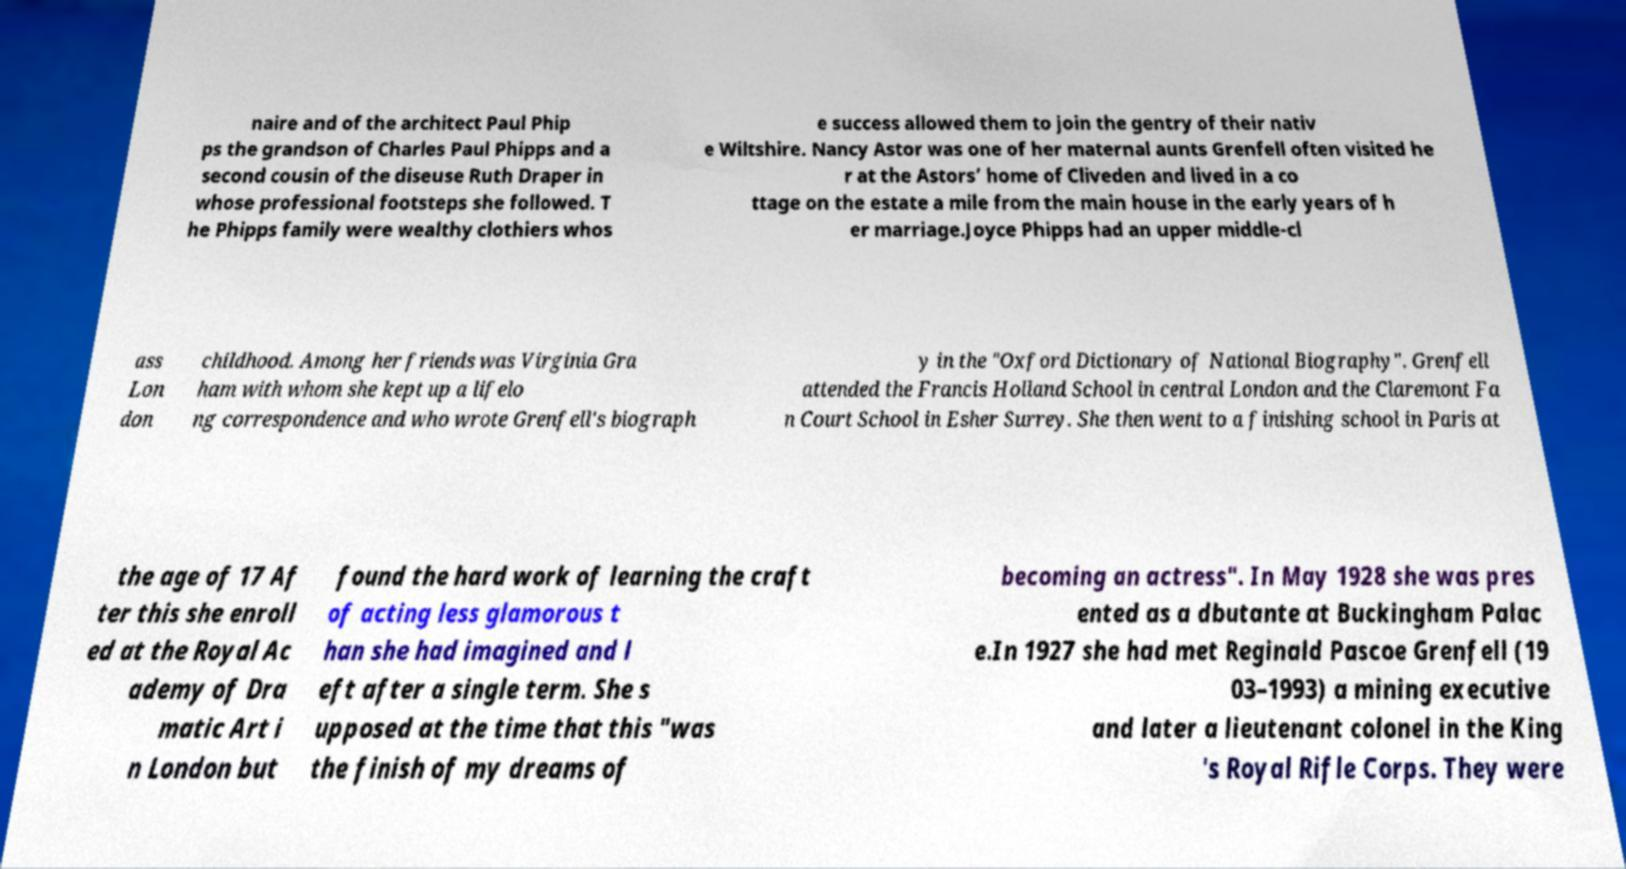What messages or text are displayed in this image? I need them in a readable, typed format. naire and of the architect Paul Phip ps the grandson of Charles Paul Phipps and a second cousin of the diseuse Ruth Draper in whose professional footsteps she followed. T he Phipps family were wealthy clothiers whos e success allowed them to join the gentry of their nativ e Wiltshire. Nancy Astor was one of her maternal aunts Grenfell often visited he r at the Astors’ home of Cliveden and lived in a co ttage on the estate a mile from the main house in the early years of h er marriage.Joyce Phipps had an upper middle-cl ass Lon don childhood. Among her friends was Virginia Gra ham with whom she kept up a lifelo ng correspondence and who wrote Grenfell's biograph y in the "Oxford Dictionary of National Biography". Grenfell attended the Francis Holland School in central London and the Claremont Fa n Court School in Esher Surrey. She then went to a finishing school in Paris at the age of 17 Af ter this she enroll ed at the Royal Ac ademy of Dra matic Art i n London but found the hard work of learning the craft of acting less glamorous t han she had imagined and l eft after a single term. She s upposed at the time that this "was the finish of my dreams of becoming an actress". In May 1928 she was pres ented as a dbutante at Buckingham Palac e.In 1927 she had met Reginald Pascoe Grenfell (19 03–1993) a mining executive and later a lieutenant colonel in the King 's Royal Rifle Corps. They were 